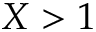<formula> <loc_0><loc_0><loc_500><loc_500>X > 1</formula> 